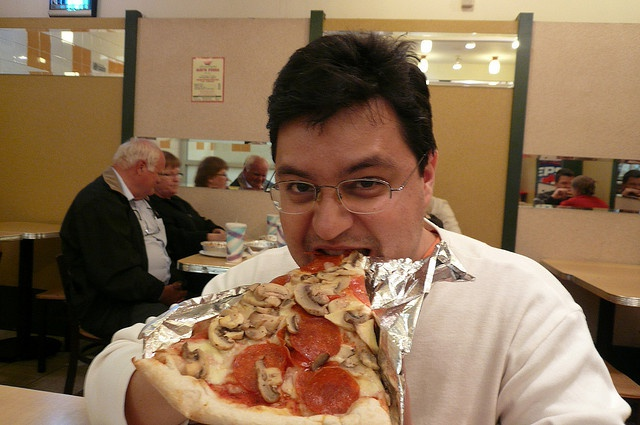Describe the objects in this image and their specific colors. I can see people in gray, ivory, black, and brown tones, pizza in gray, brown, and tan tones, people in gray, black, maroon, and darkgray tones, people in gray, black, maroon, and brown tones, and dining table in gray, tan, black, and maroon tones in this image. 